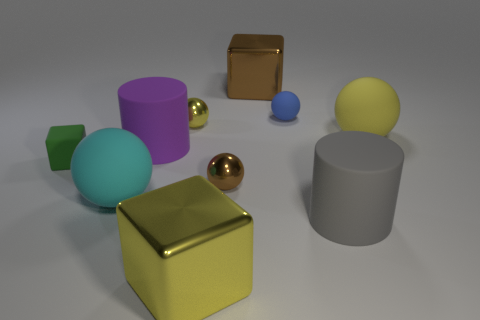Subtract all blue spheres. How many spheres are left? 4 Subtract all large cyan matte spheres. How many spheres are left? 4 Subtract all brown balls. Subtract all brown cubes. How many balls are left? 4 Subtract all cylinders. How many objects are left? 8 Add 7 purple spheres. How many purple spheres exist? 7 Subtract 0 purple cubes. How many objects are left? 10 Subtract all small green objects. Subtract all purple rubber cylinders. How many objects are left? 8 Add 7 tiny yellow metallic objects. How many tiny yellow metallic objects are left? 8 